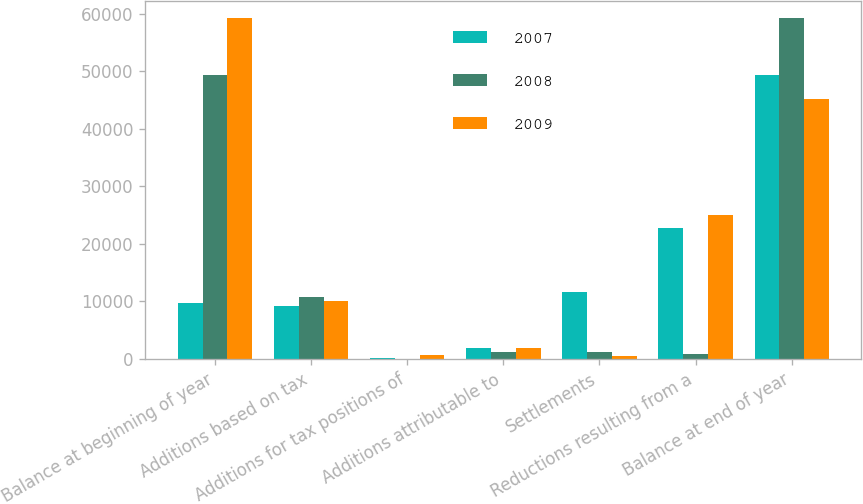Convert chart. <chart><loc_0><loc_0><loc_500><loc_500><stacked_bar_chart><ecel><fcel>Balance at beginning of year<fcel>Additions based on tax<fcel>Additions for tax positions of<fcel>Additions attributable to<fcel>Settlements<fcel>Reductions resulting from a<fcel>Balance at end of year<nl><fcel>2007<fcel>9627.5<fcel>9177<fcel>146<fcel>1934<fcel>11658<fcel>22715<fcel>49338<nl><fcel>2008<fcel>49338<fcel>10674<fcel>22<fcel>1216<fcel>1198<fcel>862<fcel>59190<nl><fcel>2009<fcel>59190<fcel>10078<fcel>633<fcel>1904<fcel>447<fcel>25025<fcel>45201<nl></chart> 